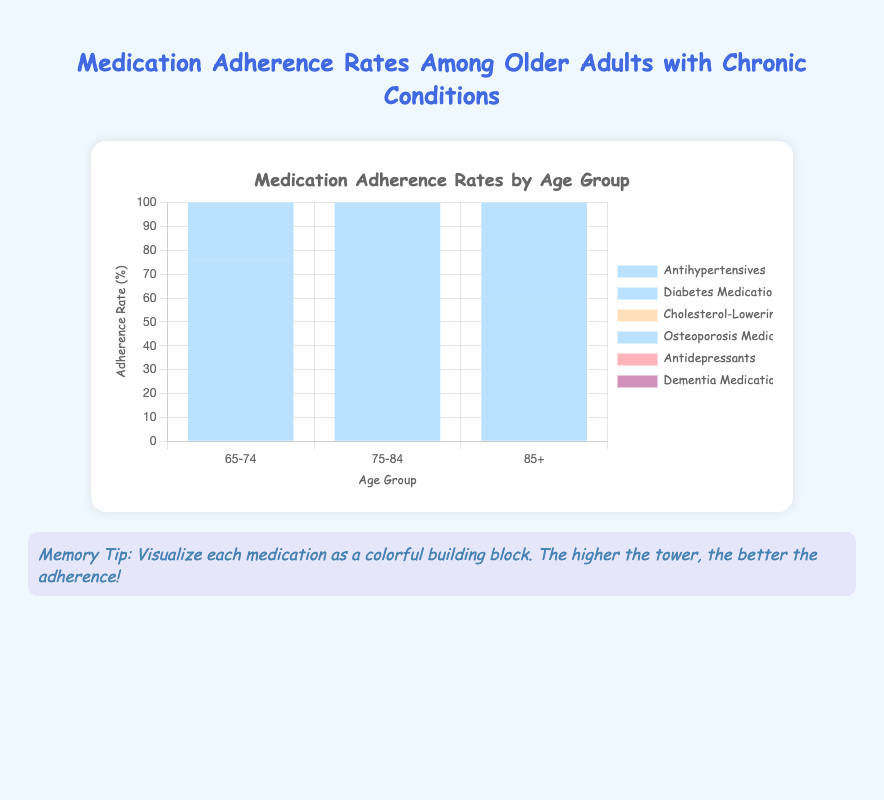Which medication type has the highest adherence rate among the 65-74 age group? Look at the segment of each medication type in the 65-74 age group and compare their heights. The tallest bar segment represents the highest adherence rate.
Answer: Diabetes Medications How much higher is the adherence rate of Diabetes Medications compared to Antidepressants in the 75-84 age group? Find the adherence rates for Diabetes Medications and Antidepressants in the 75-84 age group. Then, subtract the adherence rate of Antidepressants from the adherence rate of Diabetes Medications: 75 - 65 = 10.
Answer: 10 What is the combined adherence rate for Antihypertensives across all age groups? Add the adherence rates for Antihypertensives in each age group: 76 (65-74) + 68 (75-84) + 60 (85+). This sum gives the combined adherence rate: 76 + 68 + 60 = 204.
Answer: 204 Which age group has the lowest adherence rate for Dementia Medications? Compare the heights of the bars for Dementia Medications across the three age groups and identify the shortest one.
Answer: 85+ What is the average adherence rate for Osteoporosis Medications across all age groups? Sum the adherence rates for Osteoporosis Medications in each age group and divide by the number of age groups: (74 + 66 + 58) / 3 = 66.
Answer: 66 In which age group is the difference between adherence rates for Diabetes Medications and Antidepressants greatest? Calculate the differences between adherence rates of Diabetes Medications and Antidepressants for each age group: (65-74: 82-71=11), (75-84: 75-65=10), (85+: 65-59=6). Compare these differences to find the greatest one.
Answer: 65-74 Do antihypertensive medications follow a consistent trend in adherence rates with increasing age? Observe the heights of the bars for Antihypertensives across increasing age groups. Check if they show a consistent increase or decrease.
Answer: Decrease What visual characteristic differentiates the adherence rates of cholesterol-lowering medications in the 85+ age group compared to the 65-74 age group? Notice the height difference between the bars for cholesterol-lowering medications in the 85+ and 65-74 age groups; the 85+ bar is shorter, indicating a lower adherence rate.
Answer: Shorter height What is the difference in adherence rates between the youngest and oldest age groups for Osteoporosis Medications? Subtract the adherence rate for Osteoporosis Medications in the 85+ group from the 65-74 group: 74 - 58 = 16.
Answer: 16 